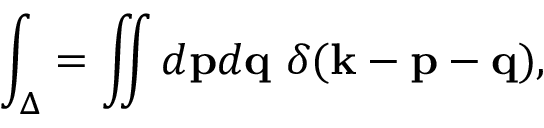<formula> <loc_0><loc_0><loc_500><loc_500>\int _ { \Delta } = \iint d { p } d { q } \ \delta ( { k } - { p } - { q } ) ,</formula> 